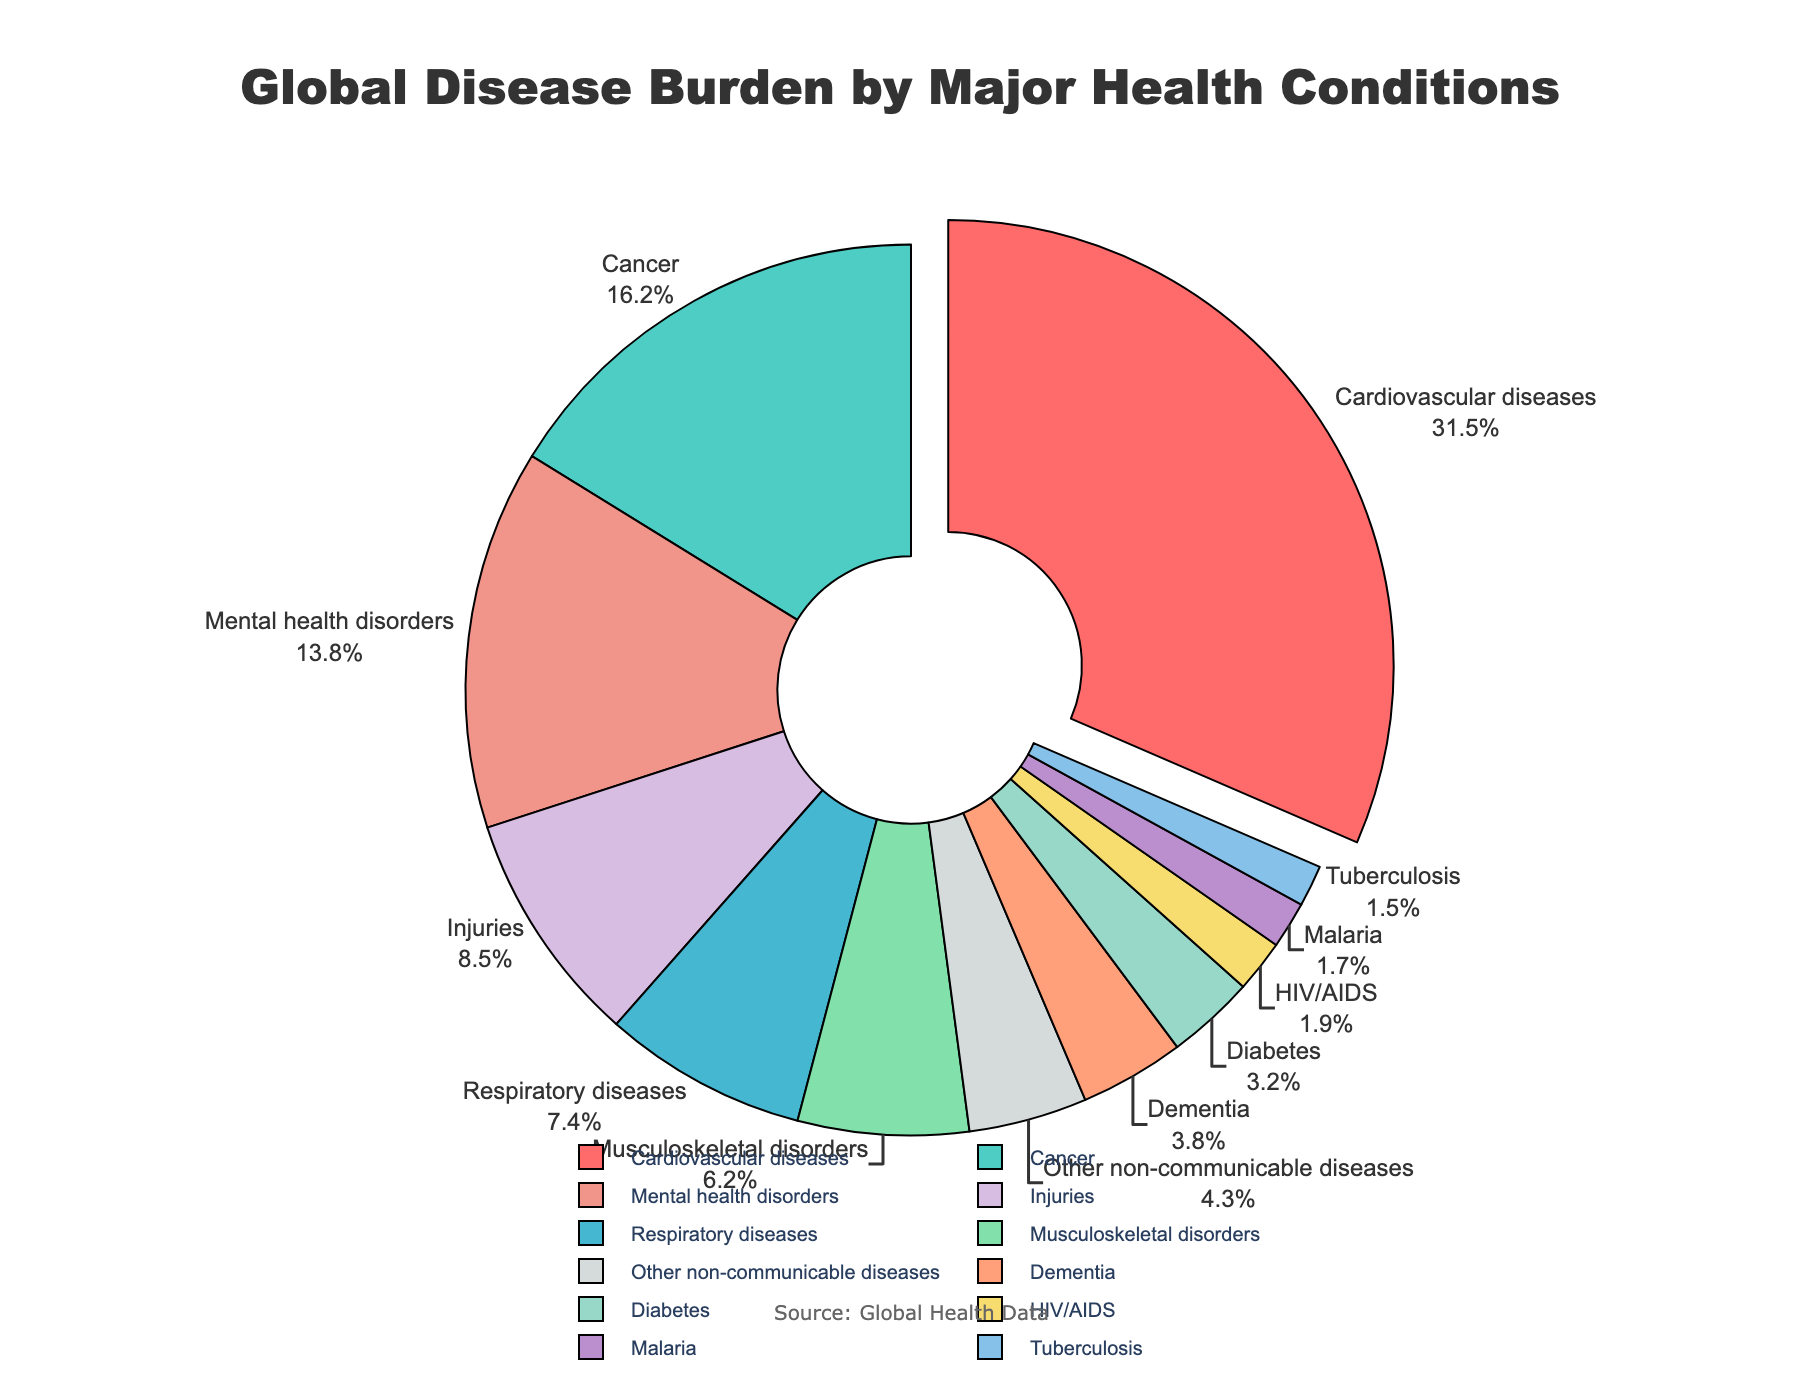What is the percentage of the global disease burden attributed to mental health disorders? Locate the segment labeled "Mental health disorders" in the pie chart and note the percentage value given.
Answer: 13.8% Which health condition has the largest percentage of the global disease burden? Identify the segment that is slightly pulled out from the pie chart, which indicates the condition with the highest percentage. It is labeled "Cardiovascular diseases" with 31.5%.
Answer: Cardiovascular diseases How does the percentage of the burden from cancer compare to that from diabetes? Find the segments labeled "Cancer" and "Diabetes" and note their percentages. Cancer is 16.2%, and diabetes is 3.2%. Cancer has a larger share.
Answer: Cancer is larger What is the combined percentage of the disease burden from HIV/AIDS, malaria, and tuberculosis? Sum the percentages for HIV/AIDS (1.9%), malaria (1.7%), and tuberculosis (1.5%). The total is 1.9 + 1.7 + 1.5 = 5.1%.
Answer: 5.1% Which condition has the smallest percentage, and what is that percentage? Locate the segment with the smallest slice in the pie chart. It is labeled "Tuberculosis" with a percentage of 1.5%.
Answer: Tuberculosis, 1.5% What is the percentage difference between cardiovascular diseases and injuries? Note the percentages for cardiovascular diseases (31.5%) and injuries (8.5%). Calculate the difference: 31.5 - 8.5 = 23%.
Answer: 23% What are the two health conditions with almost equal percentages, and what are their values? Compare segments until you identify those with close values. "Respiratory diseases" (7.4%) and "Musculoskeletal disorders" (6.2%) are close.
Answer: Respiratory diseases (7.4%) and Musculoskeletal disorders (6.2%) What color represents the segment for cancer? Identify the segment labeled "Cancer" and note its visual color, which is turquoise.
Answer: Turquoise How much larger is the mental health disorders burden compared to respiratory diseases in percentage points? Note the percentages for mental health disorders (13.8%) and respiratory diseases (7.4%). Calculate the difference: 13.8 - 7.4 = 6.4.
Answer: 6.4 What is the median value of the percentages for all the health conditions? List all percentages in ascending order: [1.5, 1.7, 1.9, 3.2, 3.8, 4.3, 6.2, 7.4, 8.5, 13.8, 16.2, 31.5]. The median value is the middle value in this ordered list, which is (4.3+6.2)/2 = 5.25.
Answer: 5.25 